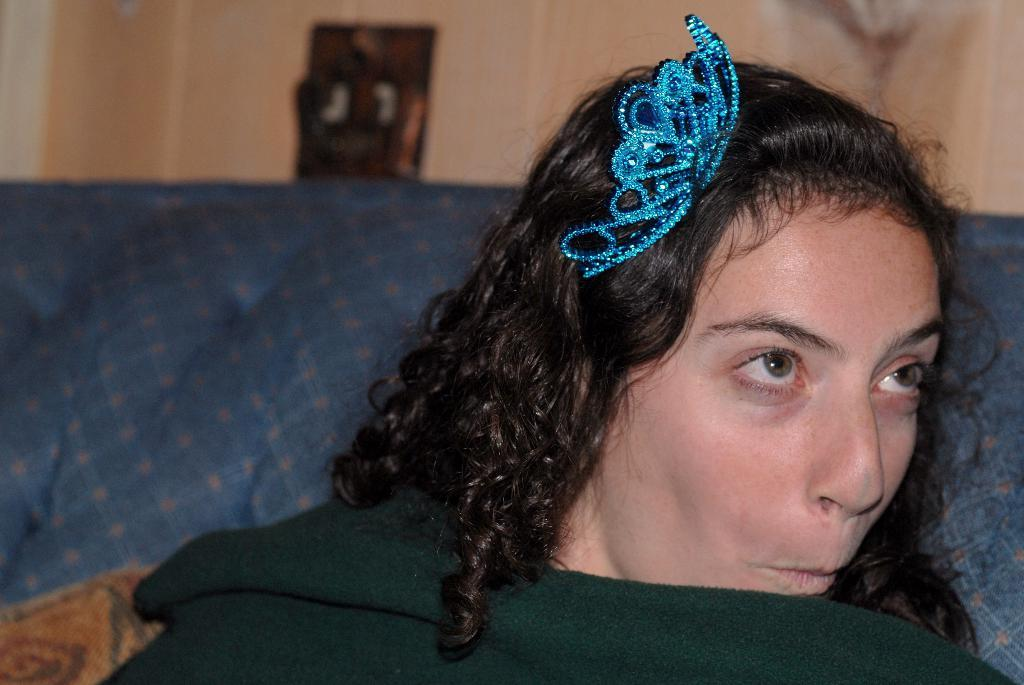Who is the main subject in the image? There is a woman in the image. What is the woman wearing on her head? The woman is wearing a blue object on her head. What can be seen in the background of the image? There is a wall in the background of the image. How would you describe the background of the image? The background of the image is blurred. Can you hear the ladybug buzzing in the image? There is no ladybug present in the image, so it cannot be heard. 